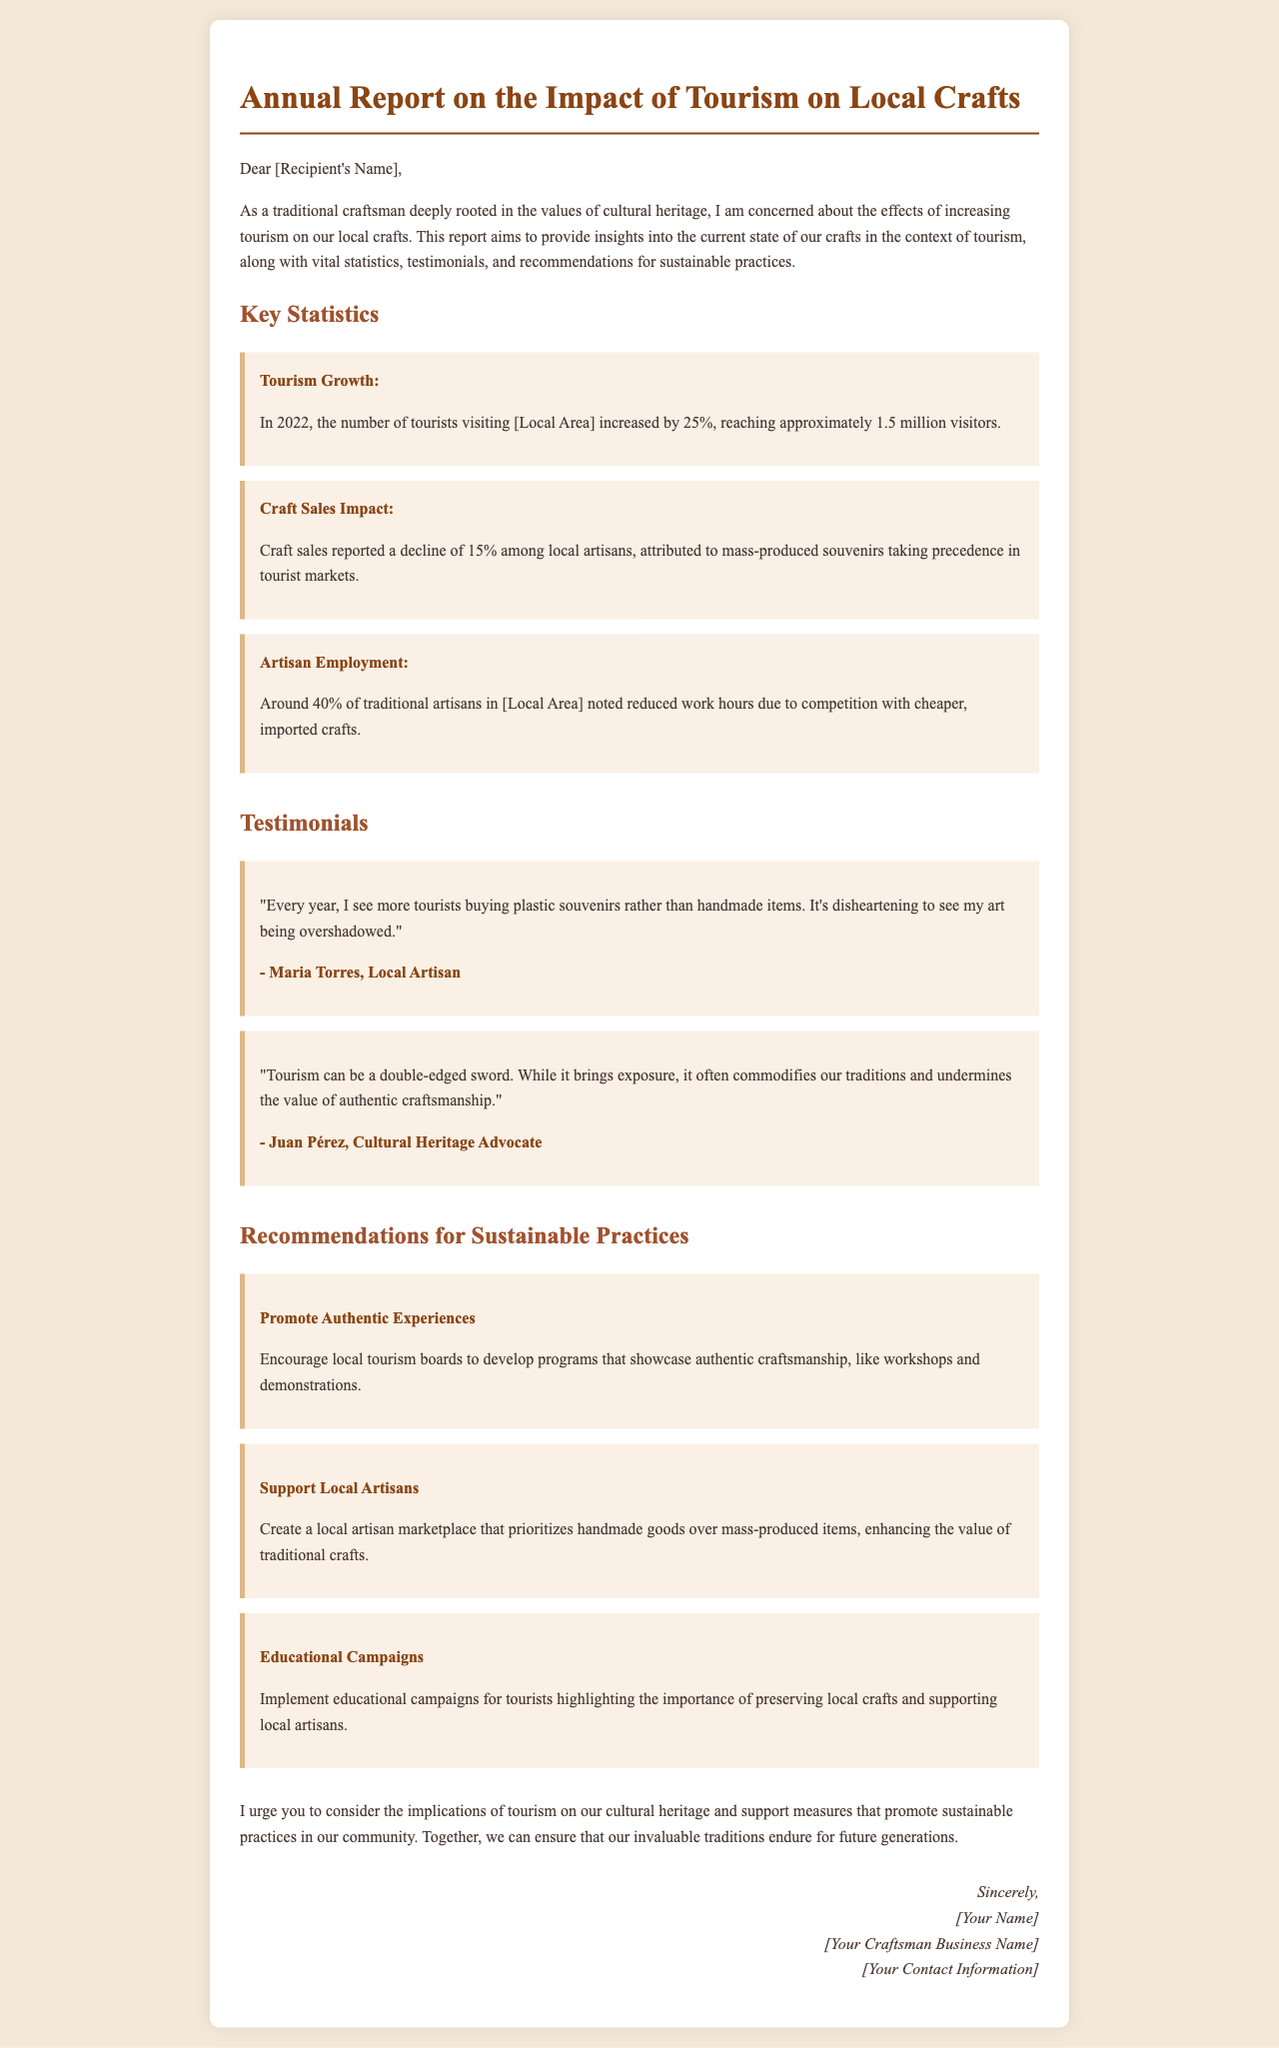What was the percentage increase in tourists in 2022? The report states that the number of tourists visiting the local area increased by 25% in 2022.
Answer: 25% What is the approximate number of tourists that visited in 2022? The document mentions that approximately 1.5 million visitors came to the local area in 2022.
Answer: 1.5 million What percentage of traditional artisans reported reduced work hours? According to the report, around 40% of traditional artisans noted reduced work hours due to competition.
Answer: 40% Who is quoted expressing concern about tourists buying plastic souvenirs? The testimony by Maria Torres highlights her concerns about tourists preferring plastic souvenirs over handmade items.
Answer: Maria Torres What is one recommendation made in the report? The report suggests promoting authentic experiences through workshops and demonstrations.
Answer: Promote Authentic Experiences How did craft sales change according to the report? The report indicates that craft sales reported a decline of 15% among local artisans.
Answer: Declined by 15% What dual aspect of tourism is mentioned by Juan Pérez? Juan Pérez notes that tourism can both bring exposure and commodify traditions.
Answer: Double-edged sword What should local tourism boards encourage according to the recommendations? The recommendations state that local tourism boards should develop programs that showcase authentic craftsmanship.
Answer: Showcase authentic craftsmanship What is the overall purpose of this annual report? The report aims to provide insights into the impact of tourism on local crafts and advocate for sustainable practices.
Answer: Advocate for sustainable practices 